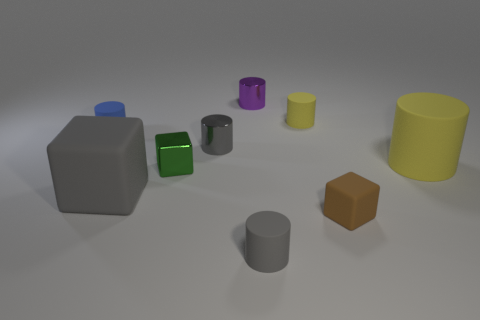There is a yellow rubber thing in front of the gray metallic thing; is it the same shape as the small gray rubber thing?
Ensure brevity in your answer.  Yes. Is the number of cylinders that are on the right side of the purple cylinder greater than the number of cyan things?
Provide a succinct answer. Yes. How many tiny cylinders are both behind the gray matte cylinder and to the right of the purple metal object?
Your answer should be compact. 1. What color is the matte thing behind the thing that is on the left side of the big gray matte cube?
Your answer should be very brief. Yellow. How many big matte blocks have the same color as the tiny shiny cube?
Your response must be concise. 0. There is a big matte block; does it have the same color as the big object that is on the right side of the big block?
Make the answer very short. No. Are there fewer tiny metallic objects than red things?
Offer a terse response. No. Are there more small gray metal cylinders on the right side of the tiny yellow thing than gray matte cylinders that are on the left side of the tiny shiny cube?
Make the answer very short. No. Is the material of the brown cube the same as the large yellow cylinder?
Provide a short and direct response. Yes. How many tiny rubber blocks are in front of the small gray matte cylinder on the right side of the green shiny thing?
Provide a short and direct response. 0. 